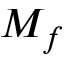<formula> <loc_0><loc_0><loc_500><loc_500>M _ { f }</formula> 